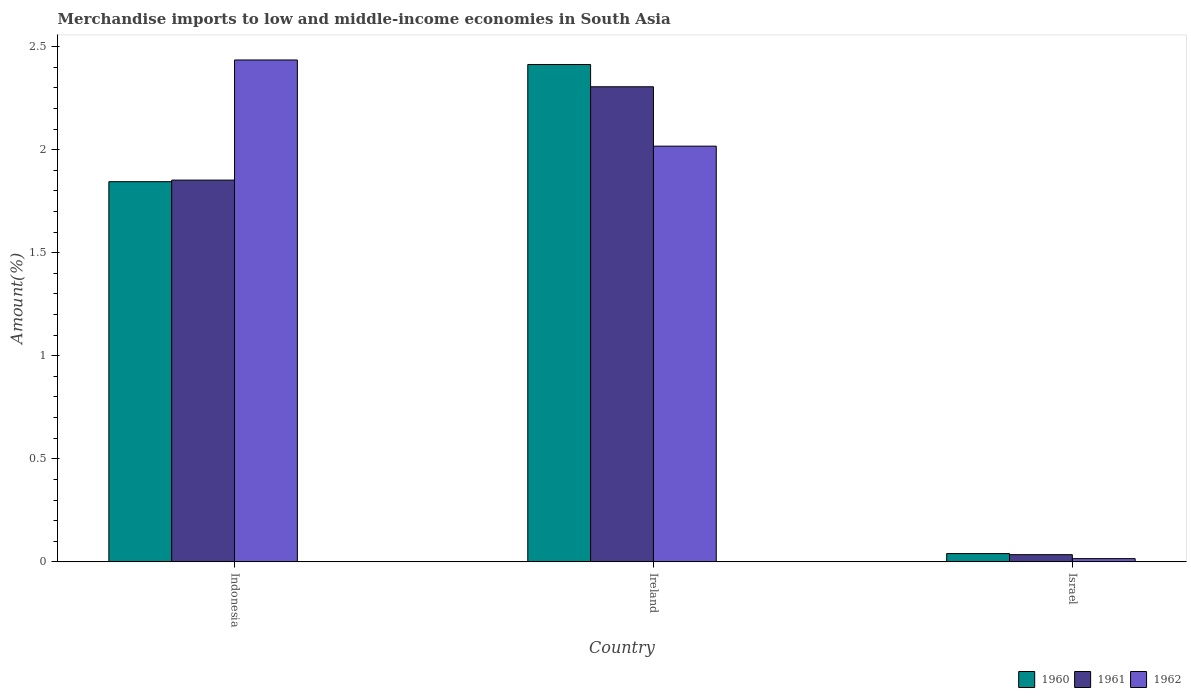How many different coloured bars are there?
Give a very brief answer. 3. How many groups of bars are there?
Your answer should be compact. 3. Are the number of bars on each tick of the X-axis equal?
Offer a terse response. Yes. How many bars are there on the 3rd tick from the left?
Offer a very short reply. 3. How many bars are there on the 1st tick from the right?
Offer a very short reply. 3. What is the percentage of amount earned from merchandise imports in 1962 in Indonesia?
Provide a short and direct response. 2.44. Across all countries, what is the maximum percentage of amount earned from merchandise imports in 1961?
Offer a terse response. 2.31. Across all countries, what is the minimum percentage of amount earned from merchandise imports in 1960?
Provide a succinct answer. 0.04. In which country was the percentage of amount earned from merchandise imports in 1960 maximum?
Offer a very short reply. Ireland. In which country was the percentage of amount earned from merchandise imports in 1960 minimum?
Your response must be concise. Israel. What is the total percentage of amount earned from merchandise imports in 1962 in the graph?
Your answer should be compact. 4.47. What is the difference between the percentage of amount earned from merchandise imports in 1962 in Ireland and that in Israel?
Make the answer very short. 2. What is the difference between the percentage of amount earned from merchandise imports in 1960 in Ireland and the percentage of amount earned from merchandise imports in 1961 in Israel?
Your response must be concise. 2.38. What is the average percentage of amount earned from merchandise imports in 1962 per country?
Your answer should be compact. 1.49. What is the difference between the percentage of amount earned from merchandise imports of/in 1962 and percentage of amount earned from merchandise imports of/in 1960 in Ireland?
Your response must be concise. -0.4. What is the ratio of the percentage of amount earned from merchandise imports in 1960 in Ireland to that in Israel?
Provide a succinct answer. 59.86. Is the percentage of amount earned from merchandise imports in 1961 in Ireland less than that in Israel?
Ensure brevity in your answer.  No. Is the difference between the percentage of amount earned from merchandise imports in 1962 in Indonesia and Israel greater than the difference between the percentage of amount earned from merchandise imports in 1960 in Indonesia and Israel?
Your answer should be compact. Yes. What is the difference between the highest and the second highest percentage of amount earned from merchandise imports in 1962?
Keep it short and to the point. -2.42. What is the difference between the highest and the lowest percentage of amount earned from merchandise imports in 1961?
Keep it short and to the point. 2.27. In how many countries, is the percentage of amount earned from merchandise imports in 1961 greater than the average percentage of amount earned from merchandise imports in 1961 taken over all countries?
Your response must be concise. 2. Is the sum of the percentage of amount earned from merchandise imports in 1962 in Indonesia and Israel greater than the maximum percentage of amount earned from merchandise imports in 1961 across all countries?
Offer a terse response. Yes. Are all the bars in the graph horizontal?
Offer a very short reply. No. What is the difference between two consecutive major ticks on the Y-axis?
Provide a short and direct response. 0.5. Are the values on the major ticks of Y-axis written in scientific E-notation?
Give a very brief answer. No. Does the graph contain grids?
Provide a short and direct response. No. How many legend labels are there?
Ensure brevity in your answer.  3. How are the legend labels stacked?
Give a very brief answer. Horizontal. What is the title of the graph?
Make the answer very short. Merchandise imports to low and middle-income economies in South Asia. Does "2002" appear as one of the legend labels in the graph?
Your response must be concise. No. What is the label or title of the Y-axis?
Offer a very short reply. Amount(%). What is the Amount(%) in 1960 in Indonesia?
Your answer should be very brief. 1.84. What is the Amount(%) of 1961 in Indonesia?
Give a very brief answer. 1.85. What is the Amount(%) in 1962 in Indonesia?
Offer a terse response. 2.44. What is the Amount(%) of 1960 in Ireland?
Your answer should be very brief. 2.41. What is the Amount(%) in 1961 in Ireland?
Offer a terse response. 2.31. What is the Amount(%) in 1962 in Ireland?
Provide a short and direct response. 2.02. What is the Amount(%) of 1960 in Israel?
Ensure brevity in your answer.  0.04. What is the Amount(%) in 1961 in Israel?
Keep it short and to the point. 0.03. What is the Amount(%) of 1962 in Israel?
Give a very brief answer. 0.02. Across all countries, what is the maximum Amount(%) in 1960?
Ensure brevity in your answer.  2.41. Across all countries, what is the maximum Amount(%) of 1961?
Provide a succinct answer. 2.31. Across all countries, what is the maximum Amount(%) of 1962?
Keep it short and to the point. 2.44. Across all countries, what is the minimum Amount(%) in 1960?
Your answer should be compact. 0.04. Across all countries, what is the minimum Amount(%) in 1961?
Your answer should be very brief. 0.03. Across all countries, what is the minimum Amount(%) in 1962?
Provide a succinct answer. 0.02. What is the total Amount(%) of 1960 in the graph?
Ensure brevity in your answer.  4.3. What is the total Amount(%) in 1961 in the graph?
Make the answer very short. 4.19. What is the total Amount(%) in 1962 in the graph?
Make the answer very short. 4.47. What is the difference between the Amount(%) in 1960 in Indonesia and that in Ireland?
Your answer should be compact. -0.57. What is the difference between the Amount(%) of 1961 in Indonesia and that in Ireland?
Your answer should be very brief. -0.45. What is the difference between the Amount(%) of 1962 in Indonesia and that in Ireland?
Your response must be concise. 0.42. What is the difference between the Amount(%) in 1960 in Indonesia and that in Israel?
Provide a short and direct response. 1.8. What is the difference between the Amount(%) of 1961 in Indonesia and that in Israel?
Provide a short and direct response. 1.82. What is the difference between the Amount(%) of 1962 in Indonesia and that in Israel?
Your answer should be very brief. 2.42. What is the difference between the Amount(%) of 1960 in Ireland and that in Israel?
Your response must be concise. 2.37. What is the difference between the Amount(%) in 1961 in Ireland and that in Israel?
Give a very brief answer. 2.27. What is the difference between the Amount(%) in 1962 in Ireland and that in Israel?
Offer a terse response. 2. What is the difference between the Amount(%) in 1960 in Indonesia and the Amount(%) in 1961 in Ireland?
Your response must be concise. -0.46. What is the difference between the Amount(%) in 1960 in Indonesia and the Amount(%) in 1962 in Ireland?
Your answer should be very brief. -0.17. What is the difference between the Amount(%) of 1961 in Indonesia and the Amount(%) of 1962 in Ireland?
Make the answer very short. -0.16. What is the difference between the Amount(%) in 1960 in Indonesia and the Amount(%) in 1961 in Israel?
Provide a succinct answer. 1.81. What is the difference between the Amount(%) in 1960 in Indonesia and the Amount(%) in 1962 in Israel?
Provide a short and direct response. 1.83. What is the difference between the Amount(%) in 1961 in Indonesia and the Amount(%) in 1962 in Israel?
Your response must be concise. 1.84. What is the difference between the Amount(%) in 1960 in Ireland and the Amount(%) in 1961 in Israel?
Your answer should be very brief. 2.38. What is the difference between the Amount(%) of 1960 in Ireland and the Amount(%) of 1962 in Israel?
Make the answer very short. 2.4. What is the difference between the Amount(%) in 1961 in Ireland and the Amount(%) in 1962 in Israel?
Provide a succinct answer. 2.29. What is the average Amount(%) of 1960 per country?
Your answer should be very brief. 1.43. What is the average Amount(%) of 1961 per country?
Make the answer very short. 1.4. What is the average Amount(%) of 1962 per country?
Your answer should be compact. 1.49. What is the difference between the Amount(%) of 1960 and Amount(%) of 1961 in Indonesia?
Offer a very short reply. -0.01. What is the difference between the Amount(%) of 1960 and Amount(%) of 1962 in Indonesia?
Your answer should be compact. -0.59. What is the difference between the Amount(%) of 1961 and Amount(%) of 1962 in Indonesia?
Your answer should be compact. -0.58. What is the difference between the Amount(%) in 1960 and Amount(%) in 1961 in Ireland?
Give a very brief answer. 0.11. What is the difference between the Amount(%) in 1960 and Amount(%) in 1962 in Ireland?
Make the answer very short. 0.4. What is the difference between the Amount(%) of 1961 and Amount(%) of 1962 in Ireland?
Provide a succinct answer. 0.29. What is the difference between the Amount(%) in 1960 and Amount(%) in 1961 in Israel?
Your response must be concise. 0.01. What is the difference between the Amount(%) of 1960 and Amount(%) of 1962 in Israel?
Your answer should be very brief. 0.02. What is the difference between the Amount(%) in 1961 and Amount(%) in 1962 in Israel?
Your answer should be compact. 0.02. What is the ratio of the Amount(%) in 1960 in Indonesia to that in Ireland?
Offer a terse response. 0.76. What is the ratio of the Amount(%) of 1961 in Indonesia to that in Ireland?
Your response must be concise. 0.8. What is the ratio of the Amount(%) in 1962 in Indonesia to that in Ireland?
Your answer should be compact. 1.21. What is the ratio of the Amount(%) in 1960 in Indonesia to that in Israel?
Give a very brief answer. 45.76. What is the ratio of the Amount(%) of 1961 in Indonesia to that in Israel?
Give a very brief answer. 53. What is the ratio of the Amount(%) of 1962 in Indonesia to that in Israel?
Your response must be concise. 154.61. What is the ratio of the Amount(%) in 1960 in Ireland to that in Israel?
Your response must be concise. 59.86. What is the ratio of the Amount(%) in 1961 in Ireland to that in Israel?
Ensure brevity in your answer.  65.96. What is the ratio of the Amount(%) in 1962 in Ireland to that in Israel?
Your answer should be very brief. 128.06. What is the difference between the highest and the second highest Amount(%) in 1960?
Offer a terse response. 0.57. What is the difference between the highest and the second highest Amount(%) of 1961?
Offer a terse response. 0.45. What is the difference between the highest and the second highest Amount(%) in 1962?
Make the answer very short. 0.42. What is the difference between the highest and the lowest Amount(%) of 1960?
Ensure brevity in your answer.  2.37. What is the difference between the highest and the lowest Amount(%) in 1961?
Provide a short and direct response. 2.27. What is the difference between the highest and the lowest Amount(%) in 1962?
Ensure brevity in your answer.  2.42. 